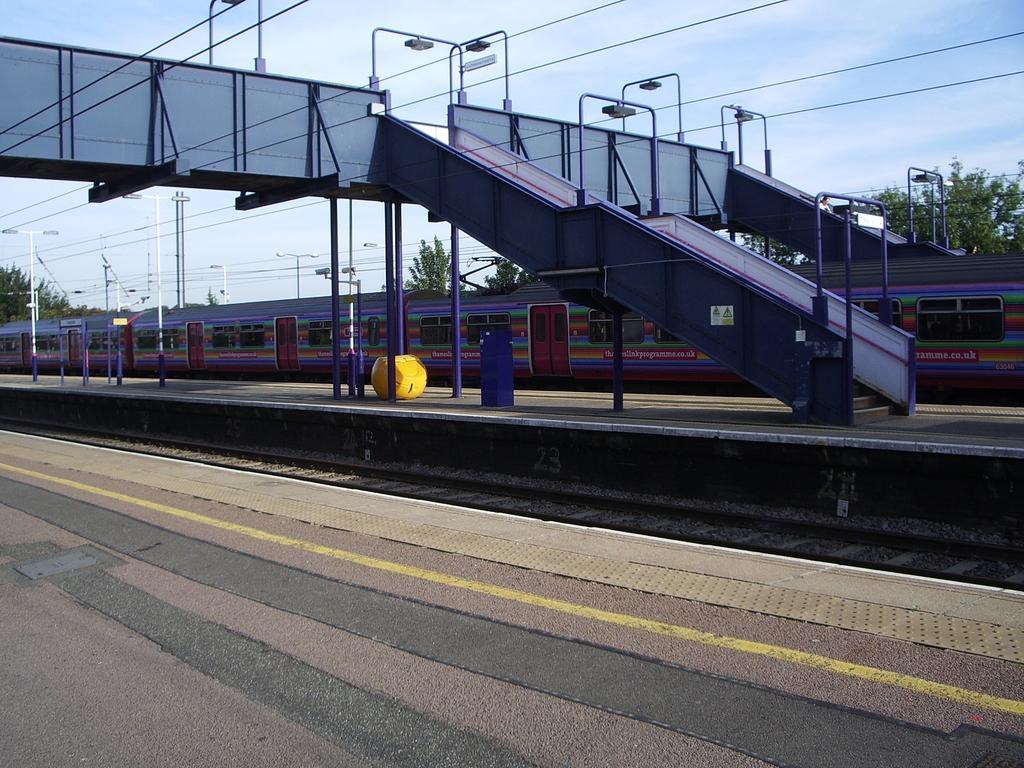Could you give a brief overview of what you see in this image? Int this center there is a train and at the top there is a bridge, staircase and some poles and lights. And at the bottom there is a walkway, railway track and in the background there are some trees and poles. At the top of the image there is sky and some wires. 